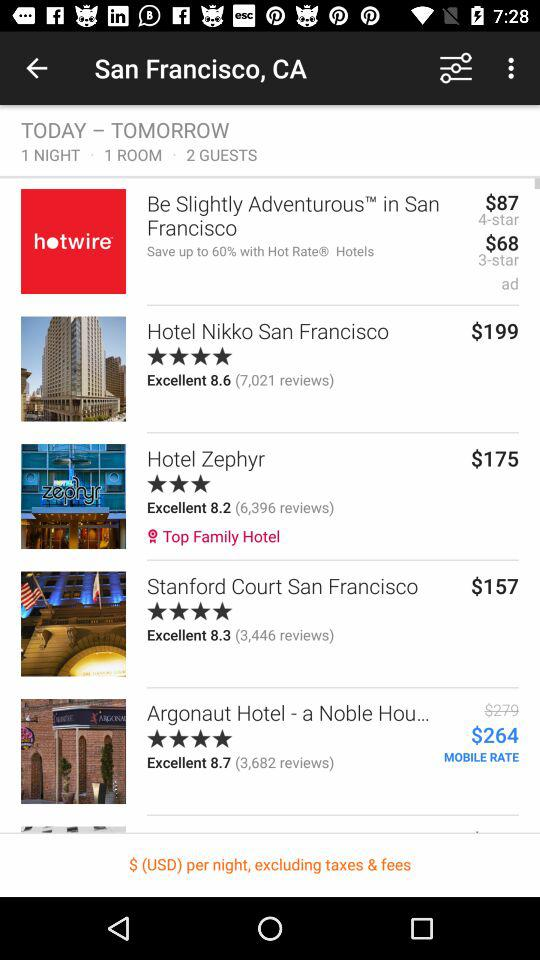What is the rent for a room at "Hotel Nikko"? The rent for a room at "Hotel Nikko" is $199. 